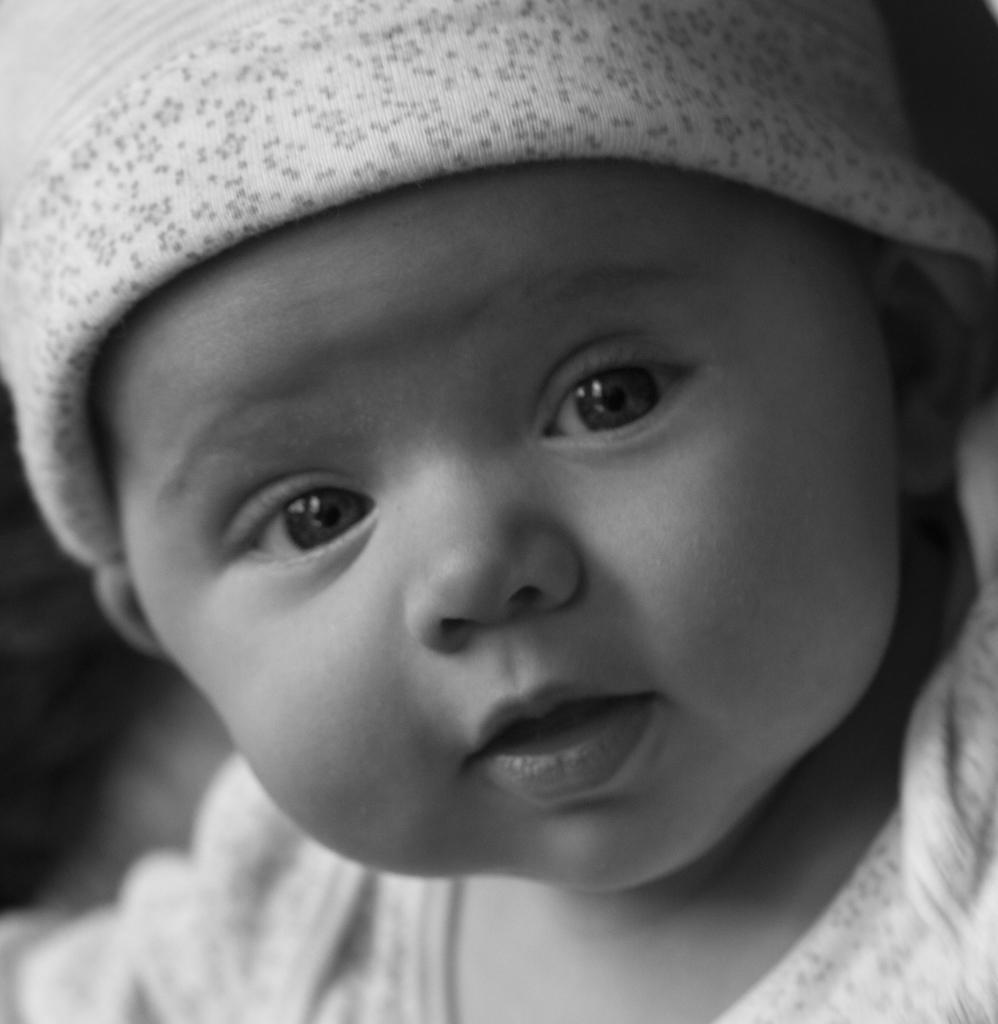Can you describe this image briefly? It is a black and white image of a baby. 